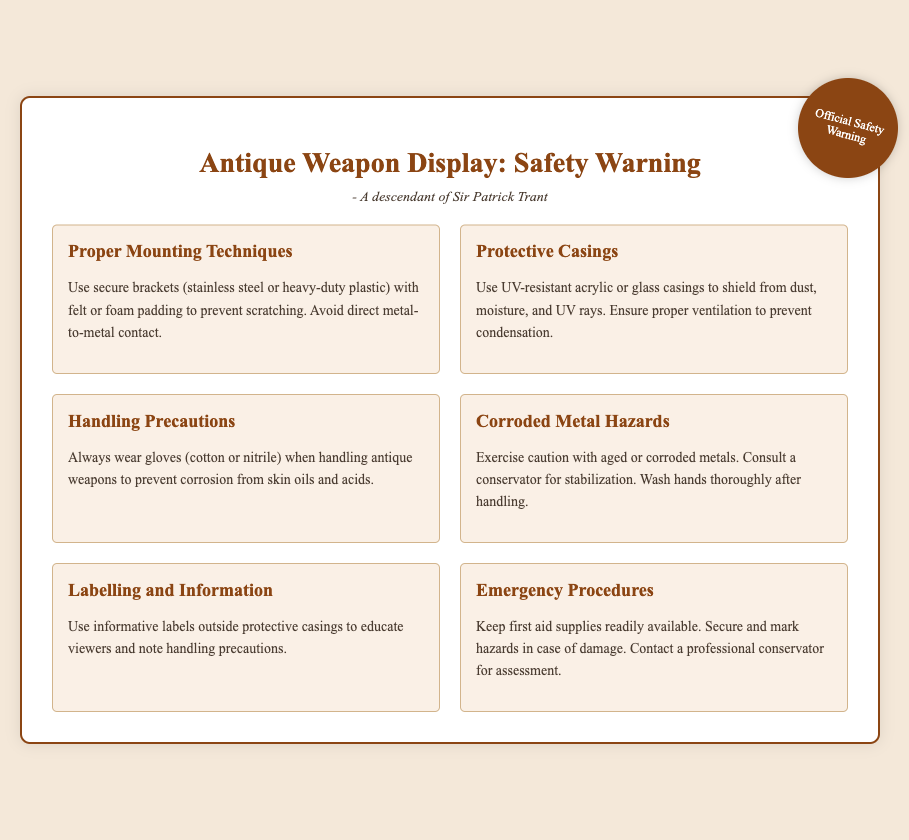what are the proper mounting materials? The document lists secure brackets that can be stainless steel or heavy-duty plastic for proper mounting.
Answer: stainless steel or heavy-duty plastic what should be used for protective casings? The warning label specifies the use of UV-resistant acrylic or glass for protective casings.
Answer: UV-resistant acrylic or glass which gloves are recommended for handling antique weapons? The document states that cotton or nitrile gloves should be worn when handling antique weapons.
Answer: cotton or nitrile what should be done if there are corroded metals? The document recommends consulting a conservator for stabilization if there are corroded metals.
Answer: consult a conservator what type of labels should be used outside the protective casings? The warning suggests using informative labels to educate viewers outside the protective casings.
Answer: informative labels what is a recommended emergency procedure? The document advises keeping first aid supplies readily available as part of the emergency procedures.
Answer: keep first aid supplies readily available how should antique weapons be handled? According to the document, antique weapons should always be handled while wearing gloves.
Answer: wearing gloves why is ventilation important in protective casings? The document notes that proper ventilation helps to prevent condensation inside protective casings.
Answer: prevent condensation 